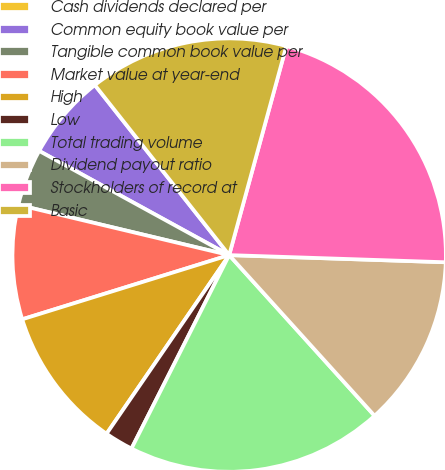<chart> <loc_0><loc_0><loc_500><loc_500><pie_chart><fcel>Cash dividends declared per<fcel>Common equity book value per<fcel>Tangible common book value per<fcel>Market value at year-end<fcel>High<fcel>Low<fcel>Total trading volume<fcel>Dividend payout ratio<fcel>Stockholders of record at<fcel>Basic<nl><fcel>0.0%<fcel>6.38%<fcel>4.26%<fcel>8.51%<fcel>10.64%<fcel>2.13%<fcel>19.15%<fcel>12.77%<fcel>21.28%<fcel>14.89%<nl></chart> 